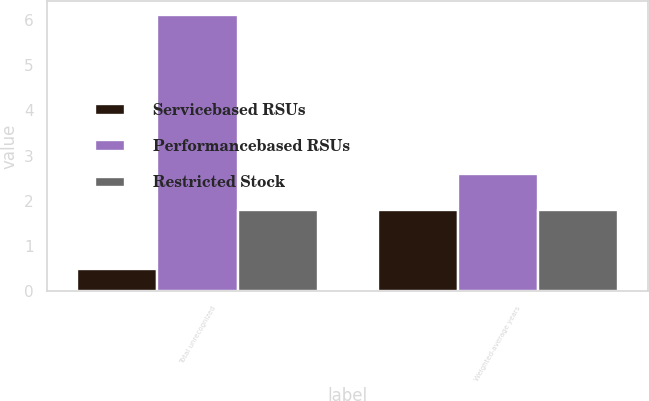Convert chart. <chart><loc_0><loc_0><loc_500><loc_500><stacked_bar_chart><ecel><fcel>Total unrecognized<fcel>Weighted-average years<nl><fcel>Servicebased RSUs<fcel>0.5<fcel>1.8<nl><fcel>Performancebased RSUs<fcel>6.1<fcel>2.6<nl><fcel>Restricted Stock<fcel>1.8<fcel>1.8<nl></chart> 